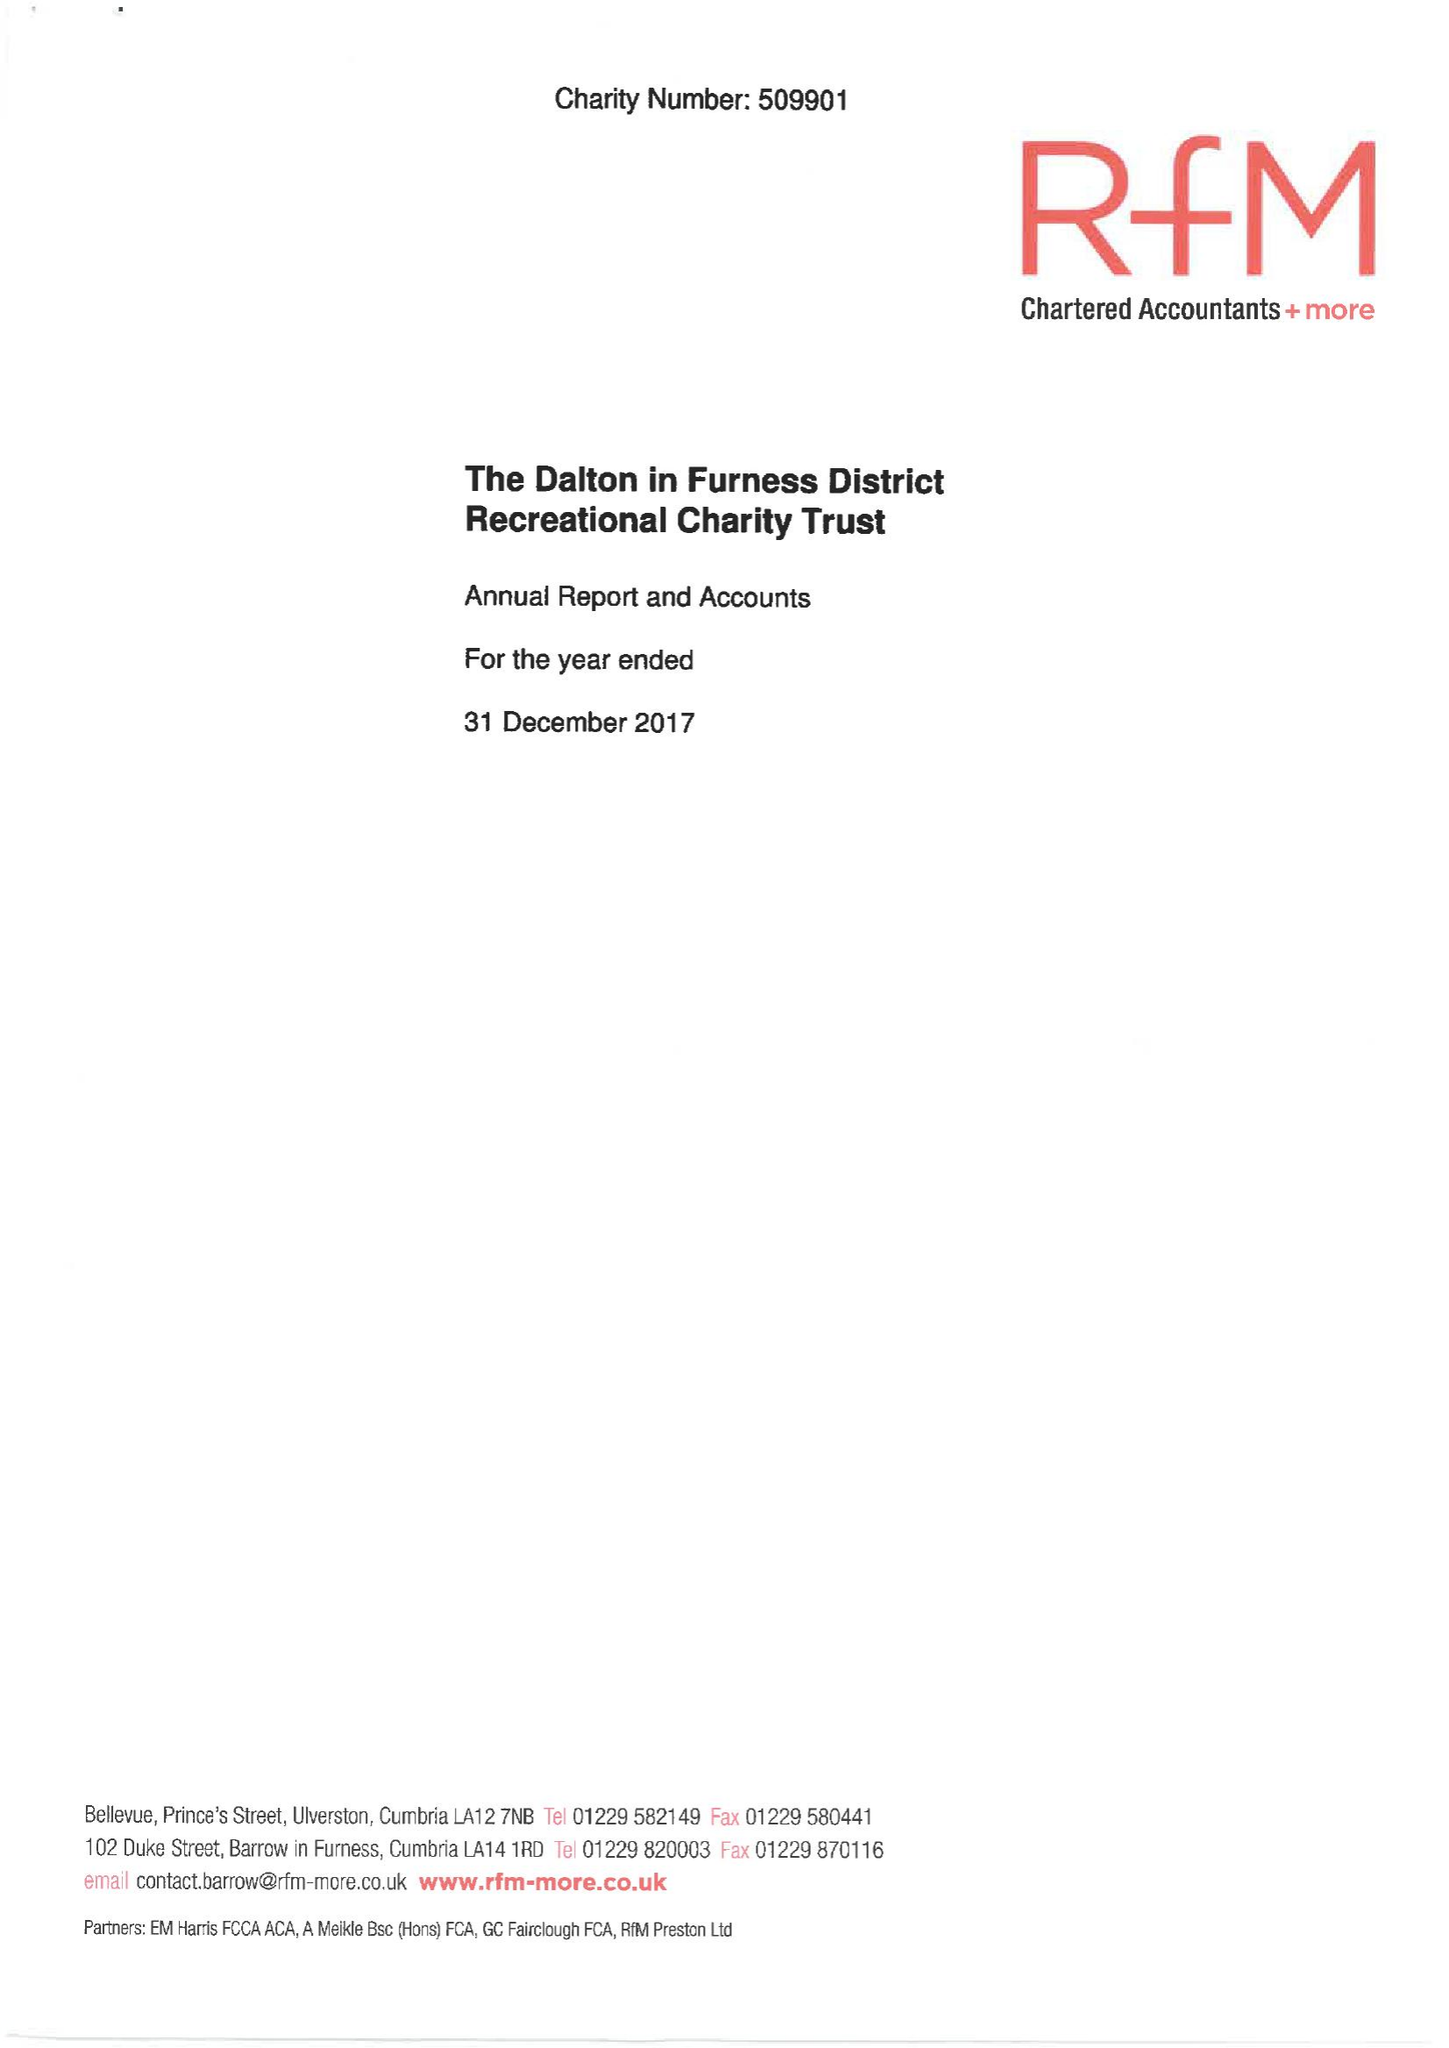What is the value for the charity_name?
Answer the question using a single word or phrase. The Dalton-In-Furness District Recreational Charity Trust 